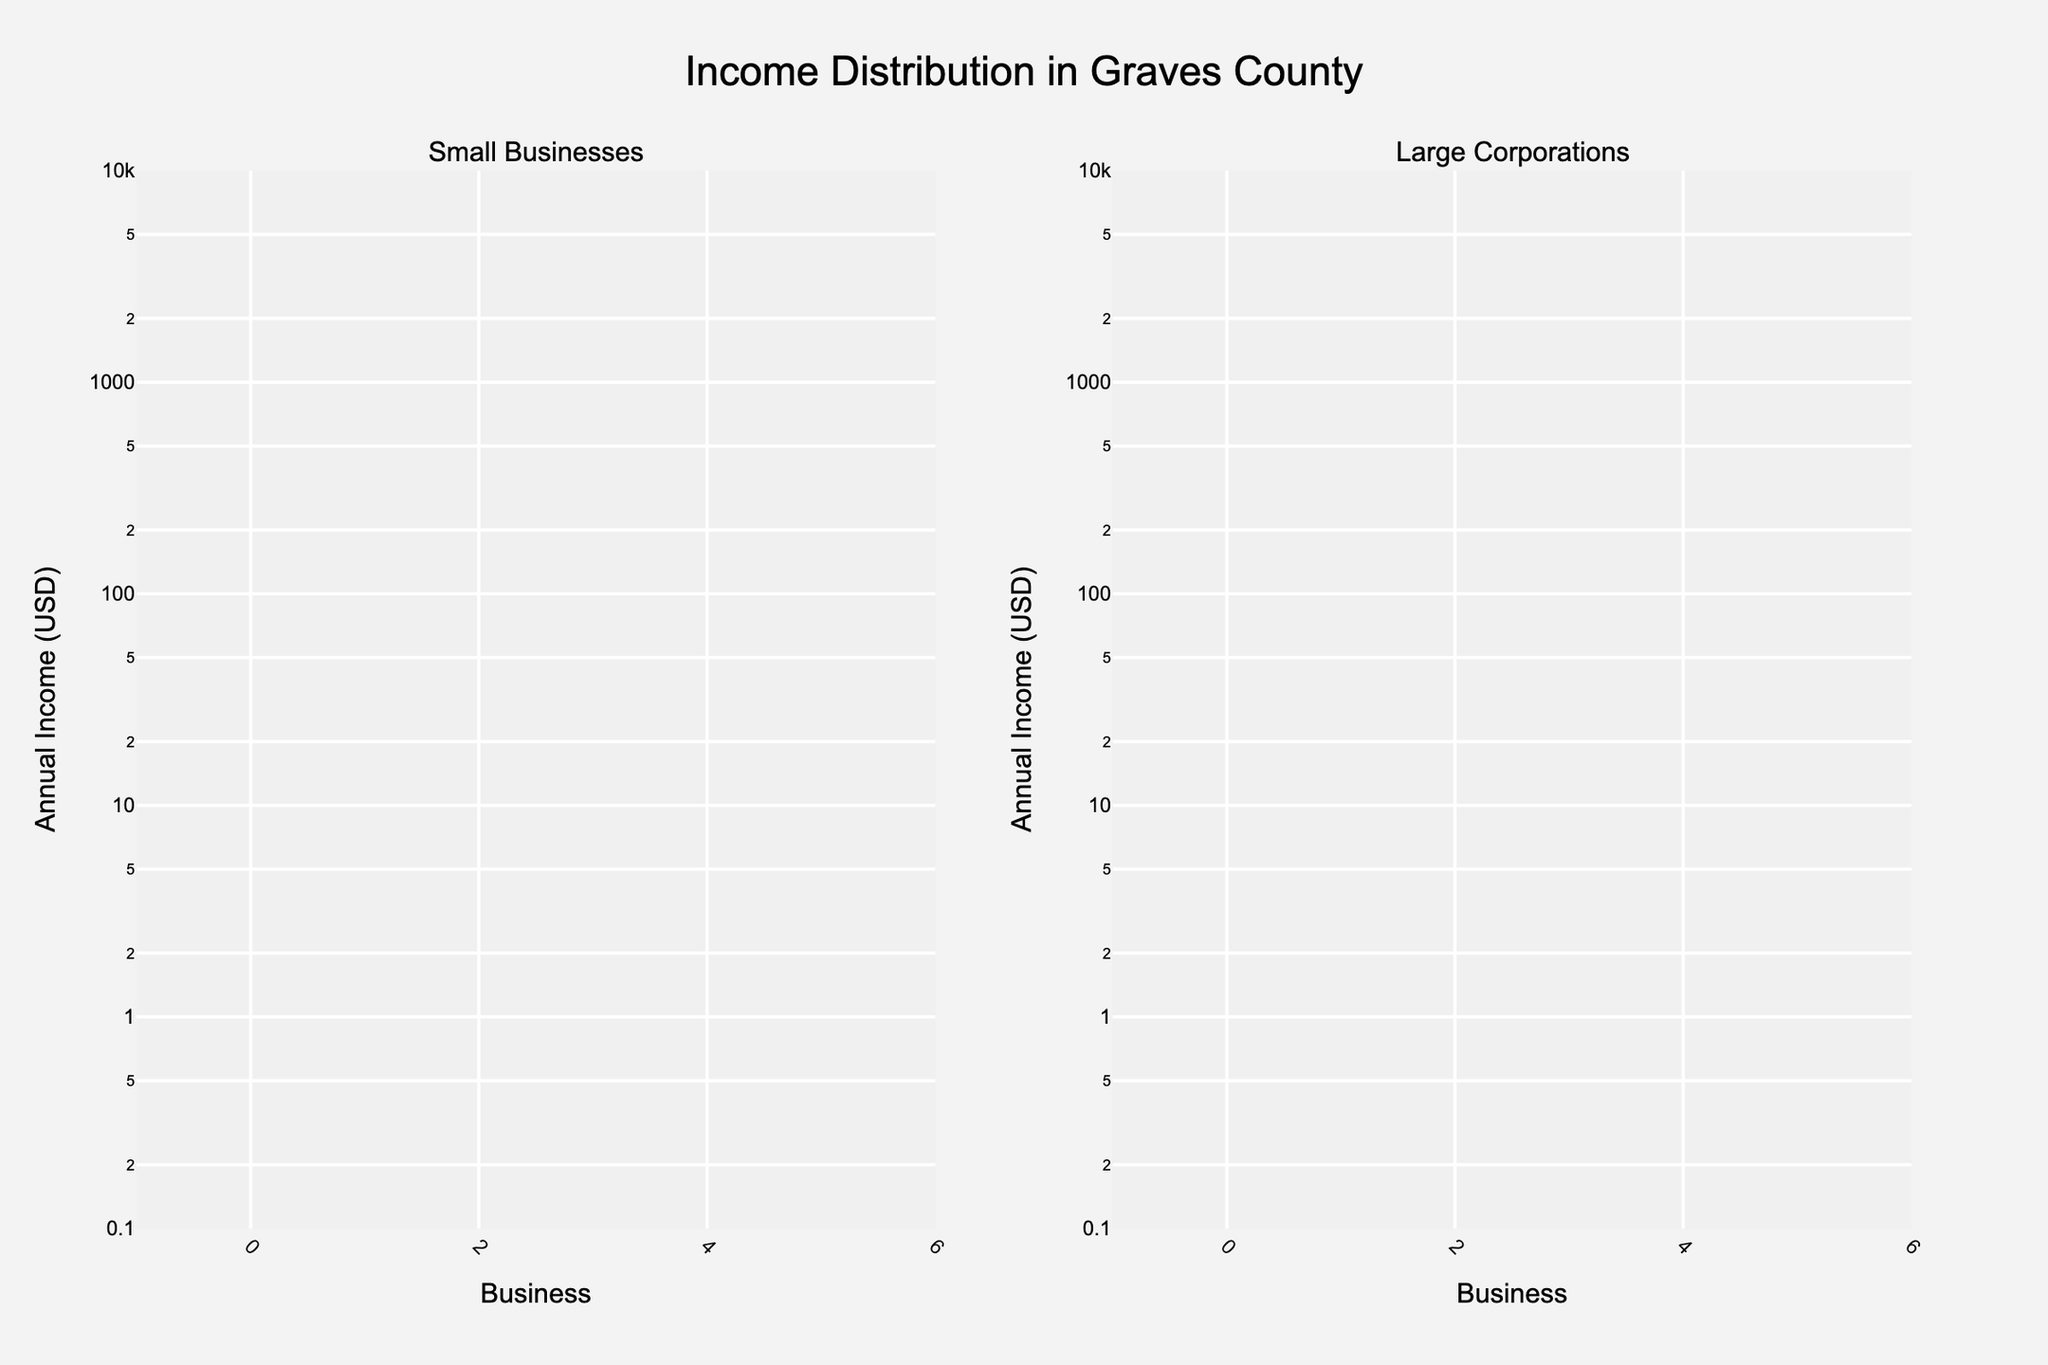What's the title of the figure? The title is located at the top center of the figure and provides an overall description of the data represented.
Answer: Income Distribution in Graves County How many small businesses are represented in the figure? Count the number of distinct bars in the subplot on the left side, which represents the small businesses. There are five bars.
Answer: 5 What is the smallest annual income among small businesses? Look at the heights of the bars in the subplot for small businesses and identify the shortest one. The smallest annual income is for BlueGrass Handicrafts, at 150,000 USD.
Answer: 150,000 USD Which large corporation has the highest annual income? Inspect the subplot on the right side for large corporations and identify the tallest bar. Ingersoll-Rand has the highest annual income at 60,000,000 USD.
Answer: Ingersoll-Rand What is the approximate average annual income of small businesses? To calculate the average, sum the annual incomes of small businesses (250,000 + 350,000 + 420,000 + 290,000 + 150,000) and divide by 5. Sum is 1,460,000, and the average is 1,460,000 / 5 = 292,000 USD.
Answer: 292,000 USD How does the annual income of the Mayfield Bakery compare to the BlueGrass Handicrafts? Compare the heights of the bars for the Mayfield Bakery and BlueGrass Handicrafts in the small businesses subplot. Mayfield Bakery has an annual income of 250,000 USD, which is higher than BlueGrass Handicrafts at 150,000 USD.
Answer: Mayfield Bakery's income is 100,000 USD higher than BlueGrass Handicrafts How does the range of annual incomes for small businesses compare to that of large corporations? Determine the range by subtracting the smallest value from the largest value for each category. For small businesses, the range is 420,000 - 150,000 = 270,000 USD. For large corporations, the range is 60,000,000 - 45,000,000 = 15,000,000 USD.
Answer: Large corporations have a wider range than small businesses What is the combined annual income of the Graves County Farmers Market and Johnson's Auto Repair? Add the annual incomes of Graves County Farmers Market (350,000 USD) and Johnson's Auto Repair (420,000 USD). The combined income is 350,000 + 420,000 = 770,000 USD.
Answer: 770,000 USD What proportion of the annual income does Walmart Supercenter contribute in comparison to all the large corporations? Calculate the total income for all large corporations and then find the proportion contributed by Walmart Supercenter. Total income is (50,000,000 + 45,000,000 + 60,000,000 + 55,000,000 + 47,000,000) = 257,000,000 USD; Walmart Supercenter's income is 50,000,000 USD. The proportion is 50,000,000 / 257,000,000 ≈ 19.46%.
Answer: 19.46% How does the visual representation of income distribution help in understanding the economic contribution of small businesses versus large corporations in Graves County? The log scale axis highlights the significant disparity in income between small businesses and large corporations. While small businesses have income values ranging from 150,000 to 420,000 USD, large corporations have substantially higher incomes ranging from 45,000,000 to 60,000,000 USD. This stark visual contrast emphasizes the dominant economic contribution of large corporations.
Answer: Large corporations contribute significantly more than small businesses 